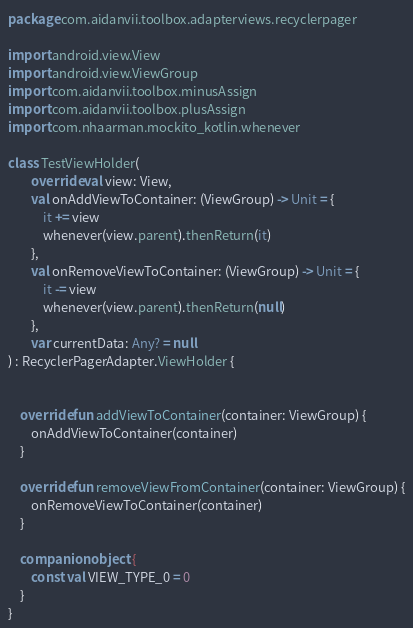<code> <loc_0><loc_0><loc_500><loc_500><_Kotlin_>package com.aidanvii.toolbox.adapterviews.recyclerpager

import android.view.View
import android.view.ViewGroup
import com.aidanvii.toolbox.minusAssign
import com.aidanvii.toolbox.plusAssign
import com.nhaarman.mockito_kotlin.whenever

class TestViewHolder(
        override val view: View,
        val onAddViewToContainer: (ViewGroup) -> Unit = {
            it += view
            whenever(view.parent).thenReturn(it)
        },
        val onRemoveViewToContainer: (ViewGroup) -> Unit = {
            it -= view
            whenever(view.parent).thenReturn(null)
        },
        var currentData: Any? = null
) : RecyclerPagerAdapter.ViewHolder {


    override fun addViewToContainer(container: ViewGroup) {
        onAddViewToContainer(container)
    }

    override fun removeViewFromContainer(container: ViewGroup) {
        onRemoveViewToContainer(container)
    }

    companion object {
        const val VIEW_TYPE_0 = 0
    }
}</code> 